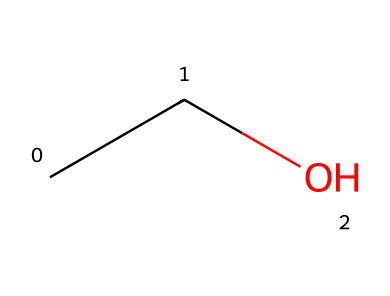What is the name of the chemical represented by this structure? The chemical with the SMILES representation "CCO" consists of an ethyl group (C2H5) connected to a hydroxyl group (OH), which defines it as ethanol.
Answer: ethanol How many carbon atoms are in this molecule? The structure "CCO" shows two carbon atoms (represented by the 'C' characters), as each 'C' represents a carbon atom in the molecular structure.
Answer: 2 What is the functional group present in ethanol? The molecule contains a hydroxyl group (-OH), which is the defining functional group for alcohols and is present in the structure of ethanol, leading to its classification as such.
Answer: hydroxyl What is the total number of hydrogen atoms in ethanol? In the structure "CCO", there are a total of six hydrogen atoms present: 5 from the ethyl group (C2H5) and 1 from the hydroxyl group (OH), totaling 6.
Answer: 6 Is ethanol a polar or nonpolar molecule? Given the presence of the hydroxyl group (-OH) in ethanol, which is highly polar, the overall molecule is polar due to the ability of the -OH group to create strong interactions with water.
Answer: polar What is the flash point of ethanol? Ethanol has a flash point of approximately 13 degrees Celsius, indicating it can ignite at lower temperatures compared to many other liquids.
Answer: 13 degrees Celsius 